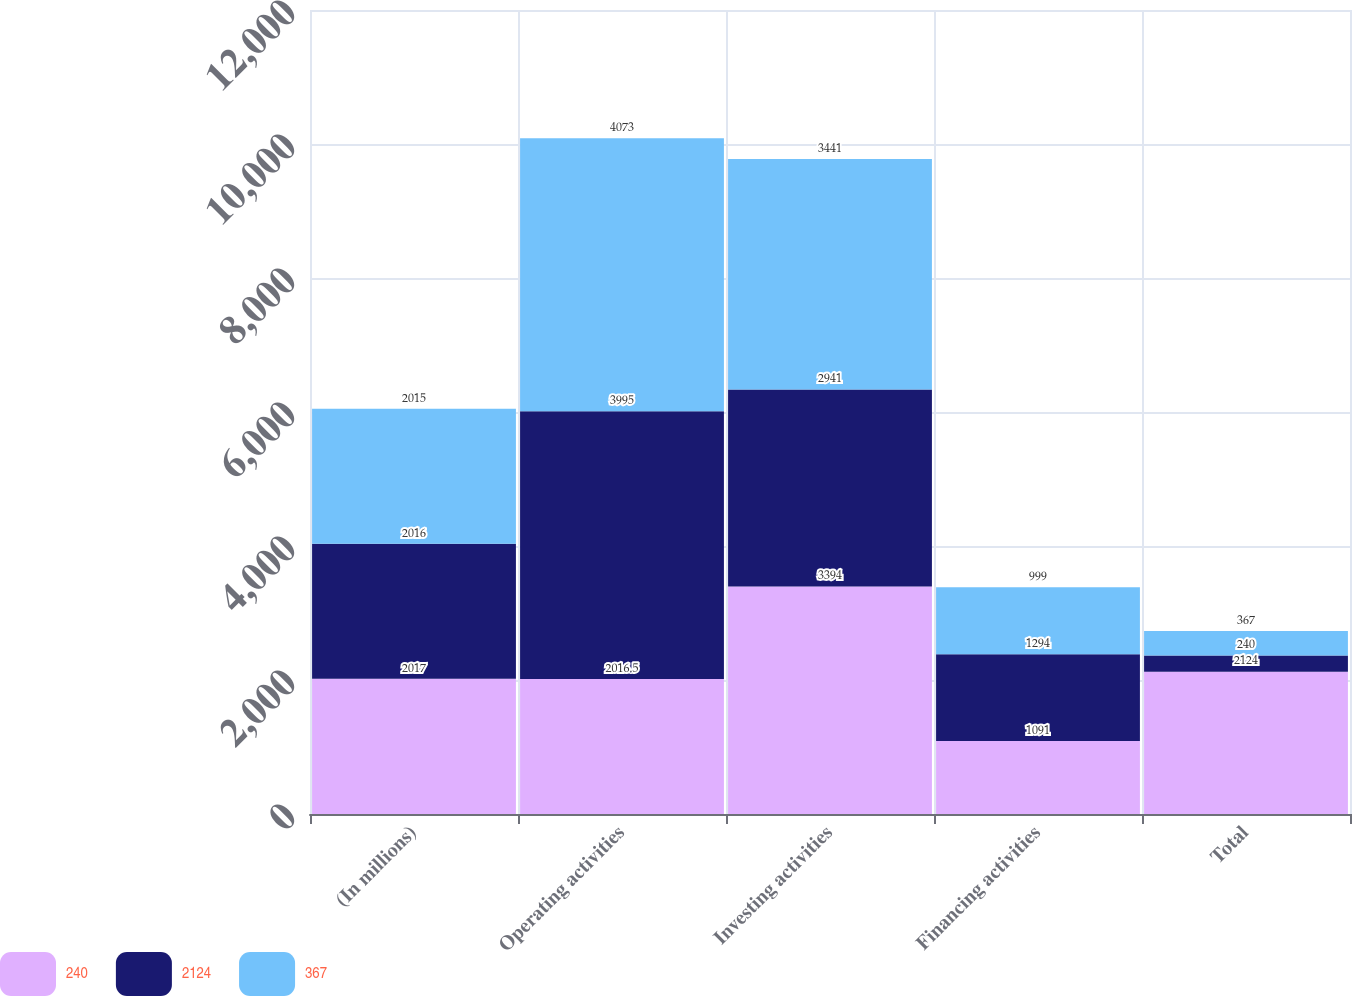Convert chart. <chart><loc_0><loc_0><loc_500><loc_500><stacked_bar_chart><ecel><fcel>(In millions)<fcel>Operating activities<fcel>Investing activities<fcel>Financing activities<fcel>Total<nl><fcel>240<fcel>2017<fcel>2016.5<fcel>3394<fcel>1091<fcel>2124<nl><fcel>2124<fcel>2016<fcel>3995<fcel>2941<fcel>1294<fcel>240<nl><fcel>367<fcel>2015<fcel>4073<fcel>3441<fcel>999<fcel>367<nl></chart> 